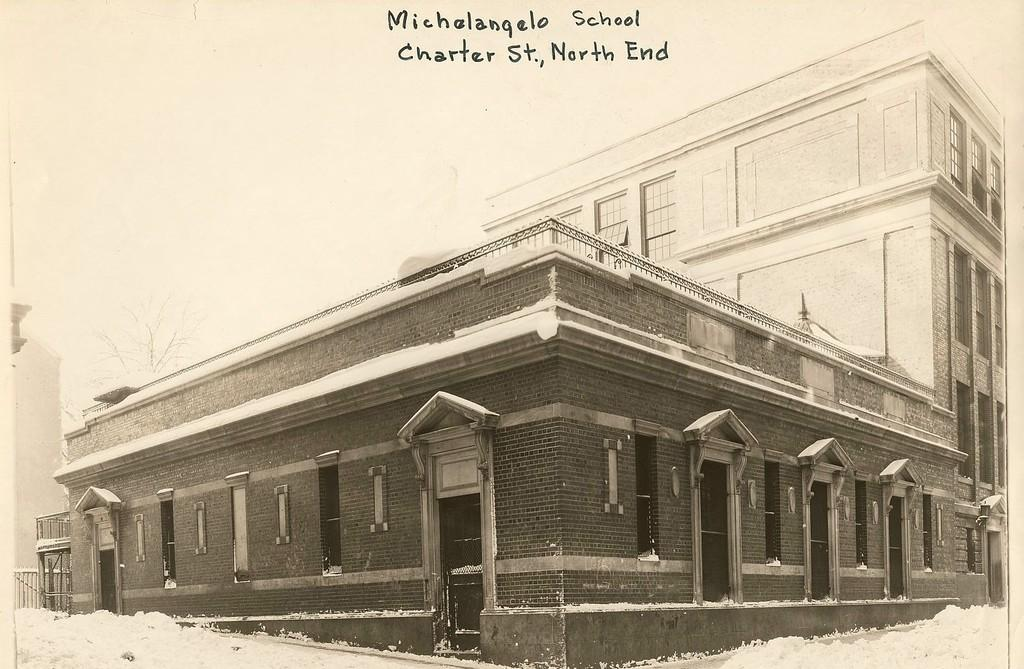What type of structures can be seen in the image? There are buildings in the image. What natural element is present in the image? There is a tree in the image. What weather condition is depicted in the image? There is snow visible in the image. What is written or displayed at the top of the image? There is text at the top of the image. How many balls are being juggled by the person in the image? There is no person present in the image, nor are there any balls visible. 